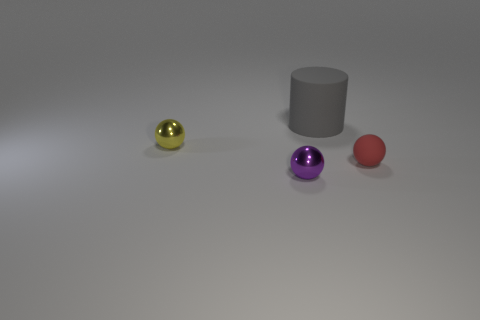Subtract all small purple spheres. How many spheres are left? 2 Add 1 tiny gray spheres. How many objects exist? 5 Subtract 1 cylinders. How many cylinders are left? 0 Subtract all balls. How many objects are left? 1 Subtract all red spheres. How many spheres are left? 2 Subtract 0 green cubes. How many objects are left? 4 Subtract all purple cylinders. Subtract all red cubes. How many cylinders are left? 1 Subtract all matte balls. Subtract all balls. How many objects are left? 0 Add 2 tiny red objects. How many tiny red objects are left? 3 Add 2 red rubber balls. How many red rubber balls exist? 3 